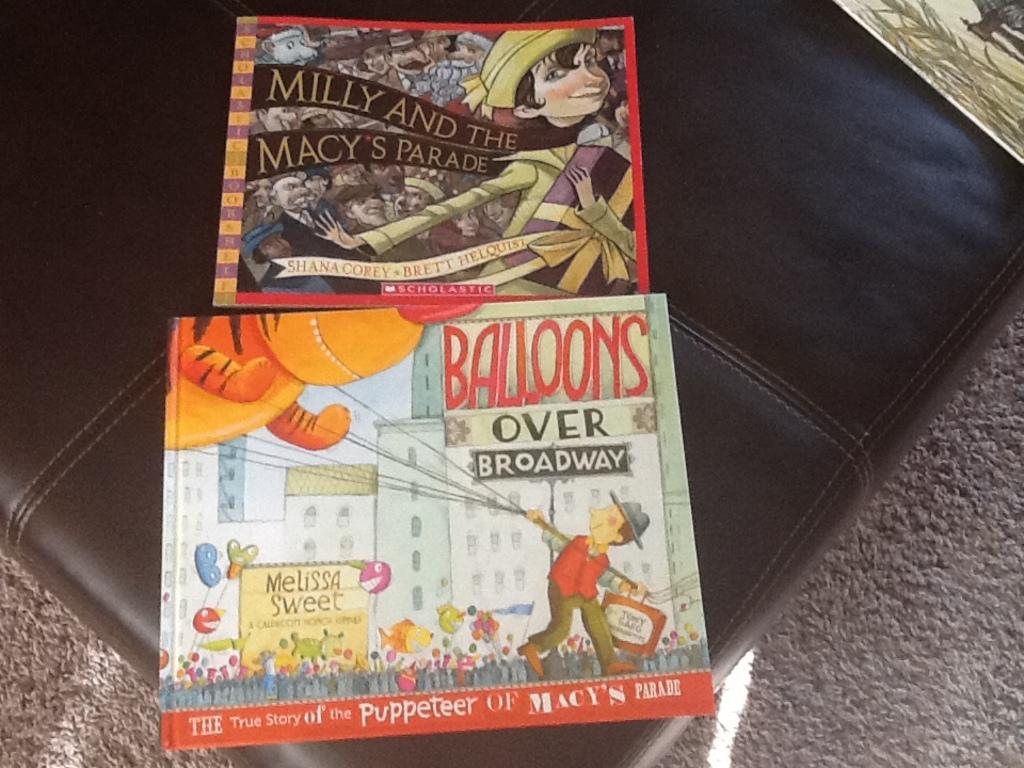Who wrote the book about balloons?
Provide a short and direct response. Melissa sweet. 